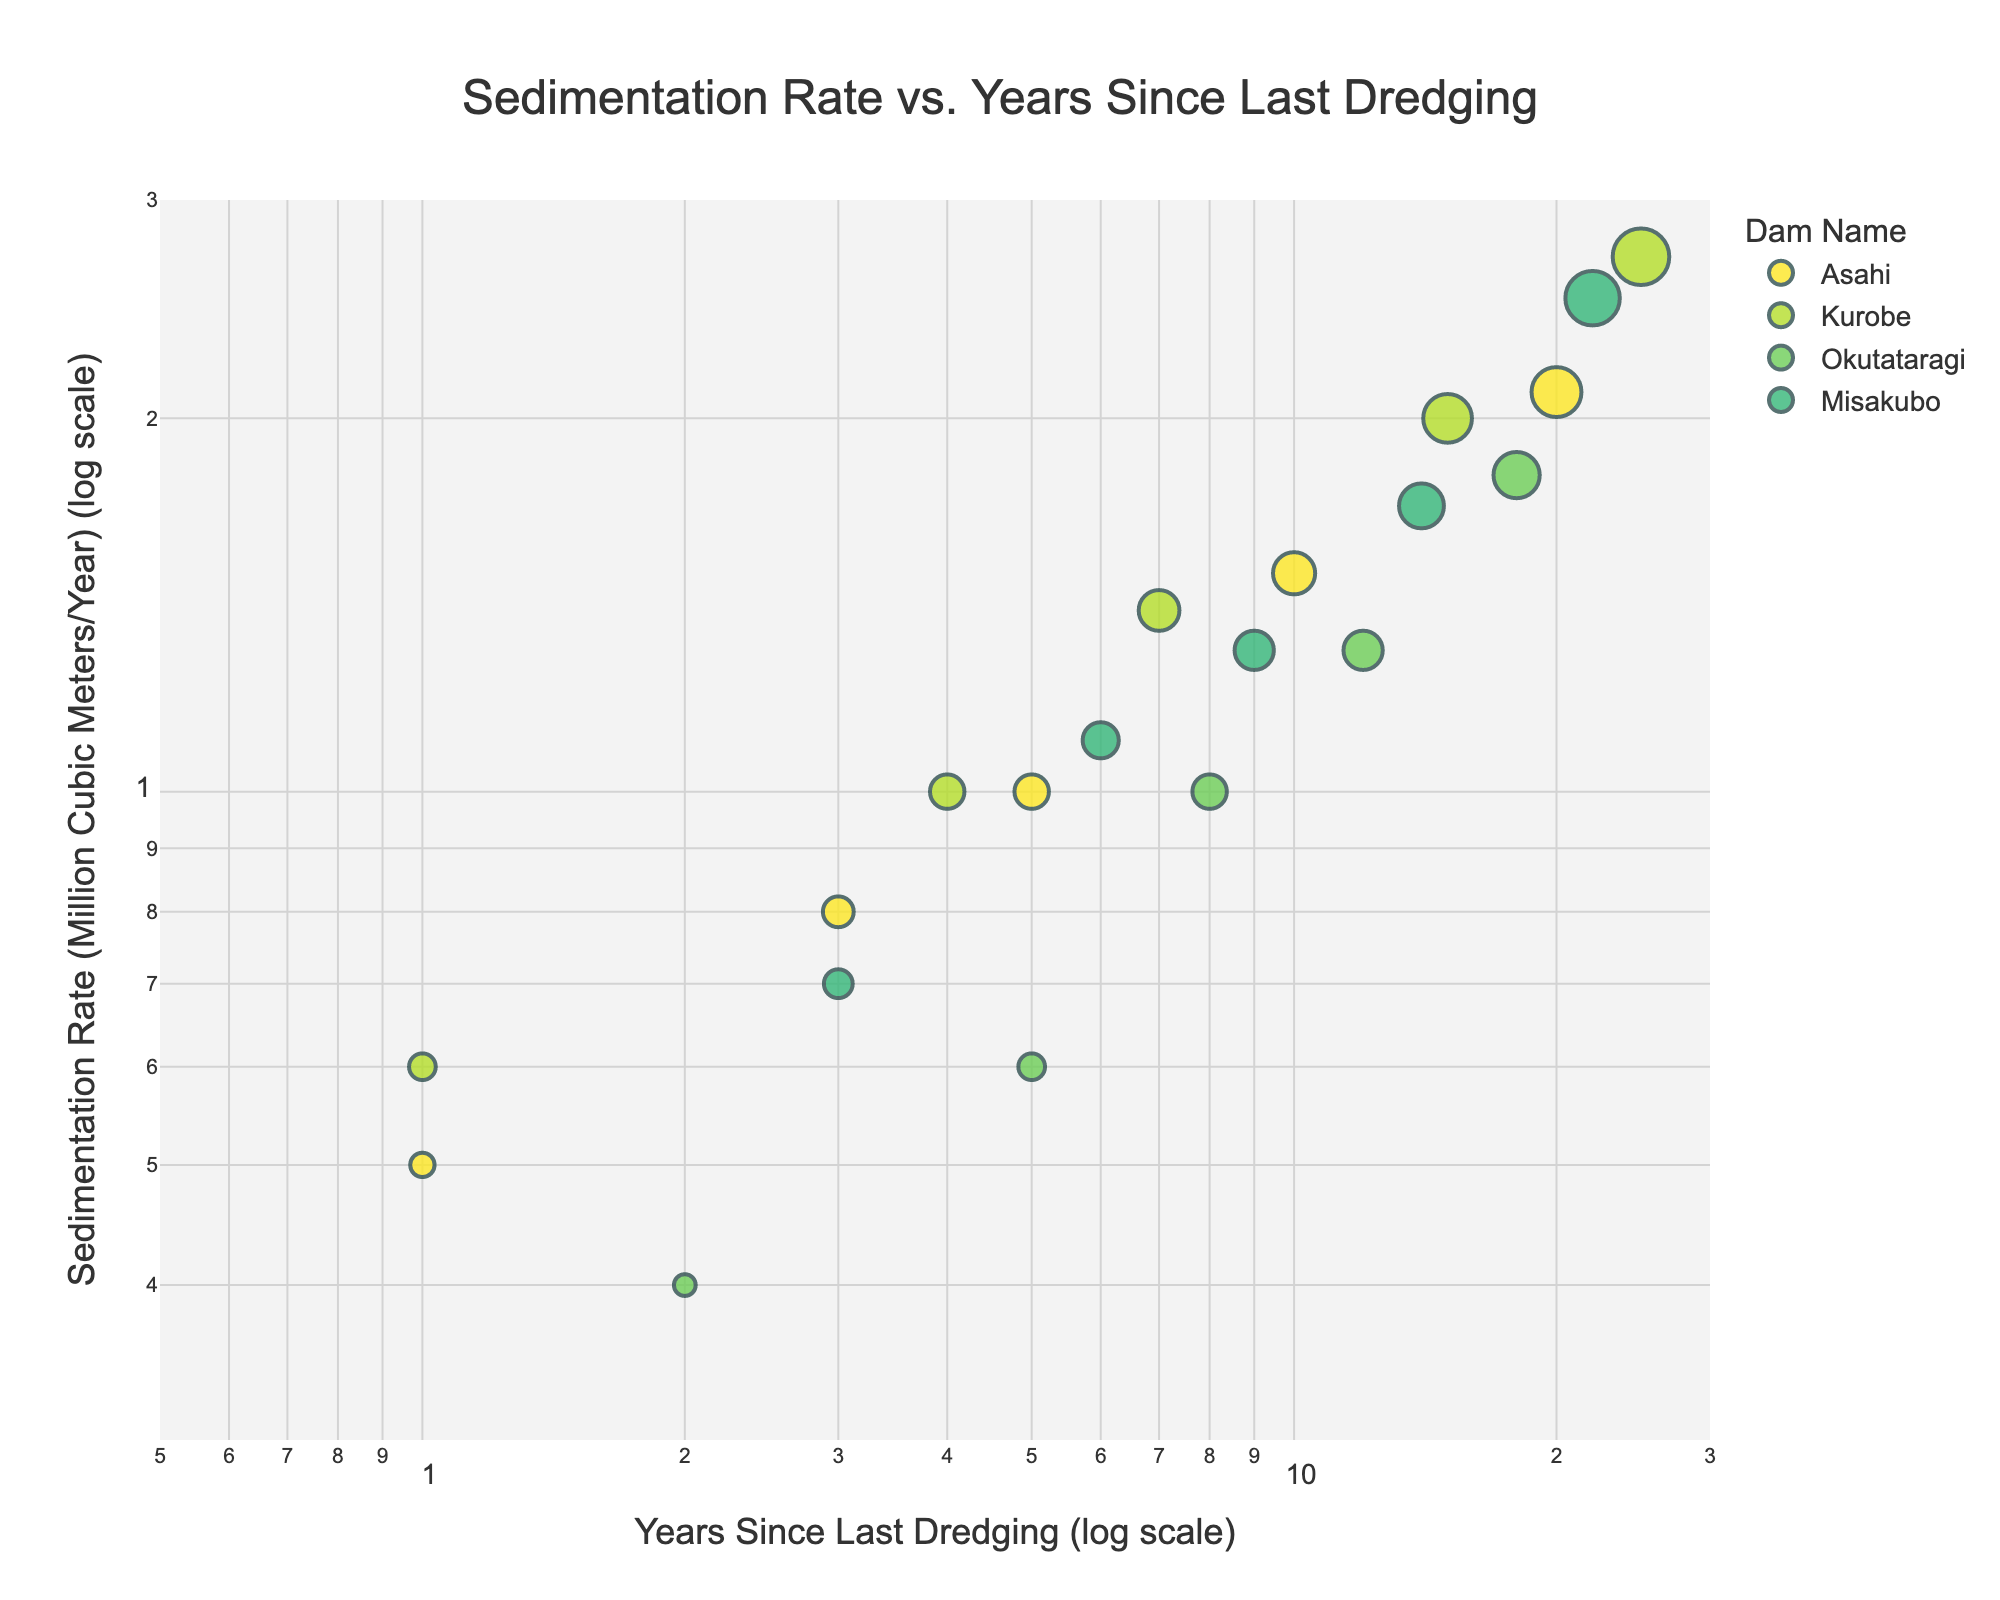What's the title of the figure? The title of the figure is written at the top center of the plot. It reads "Sedimentation Rate vs. Years Since Last Dredging."
Answer: Sedimentation Rate vs. Years Since Last Dredging What are the units of the Y-axis? The Y-axis label provides the units. It is labeled "Sedimentation Rate (Million Cubic Meters/Year) (log scale)."
Answer: Million Cubic Meters/Year How many data points represent the Asahi Dam? By checking the different colored markers corresponding to "Asahi" in the legend and counting them on the plot, we find there are five data points for Asahi Dam.
Answer: 5 For a "Years Since Last Dredging" value of 1, which dam has the highest sedimentation rate? Locate the data points where the x-axis value is 1. There are data points around this value for Asahi and Kurobe Dams. Comparing the y-axis values, the Kurobe Dam has the higher sedimentation rate of 0.6.
Answer: Kurobe What is the sedimentation rate for Kurobe Dam at 25 years since the last dredging? Find the data point for Kurobe Dam at 25 years on the x-axis. The y-axis value at this point is 2.7 million cubic meters per year.
Answer: 2.7 What is the average sedimentation rate for the Okutataragi Dam? The sedimentation rates for Okutataragi Dam are 0.4, 0.6, 1.0, 1.3, and 1.8. Summing them gives 5.1. Dividing by the number of points (5) results in an average of 1.02 million cubic meters per year.
Answer: 1.02 Which dam shows the steepest increase in sedimentation rate over time? Compare the trends of the data points for each dam. The Kurobe Dam shows the steepest increase, going from 0.6 to 2.7 million cubic meters per year over 25 years.
Answer: Kurobe Is the relationship between sedimentation rate and years since last dredging linear on a log-log scale? On a log-log scale, if the data form a straight line, the relationship is described by a power function, implying a potential non-linear relationship in linear space. Examining the data points, they roughly form a straight line for each dam, especially as time increases.
Answer: Yes What color represents the Misakubo Dam data points? The legend on the plot indicates the color used for each dam. The data points for Misakubo Dam are represented in a distinct color, which is one of the colors from the Viridis color scale.
Answer: (Color from the legend, e.g., "Yellow" depending on the color shown) Which dam has a sedimentation rate closest to 1.0 million cubic meters per year at any point? Reviewing the plot, Asahi Dam at 5 years, Kurobe Dam at 7 years, and Okutataragi Dam at 8 years show sedimentation rates close to 1.0 million cubic meters per year.
Answer: Multiple Dams (Asahi, Kurobe, Okutataragi) 